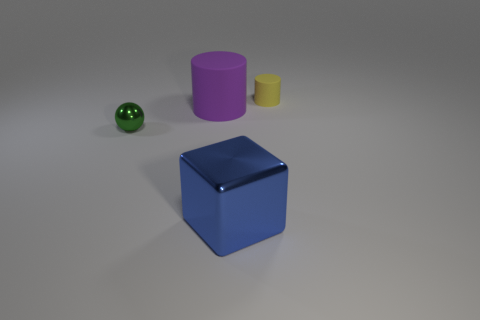Can you tell me what objects are present on the left side of the image? On the left side of the image, there is a small green sphere. This sphere has a shiny surface, reflecting the light and giving it a glossy appearance. 